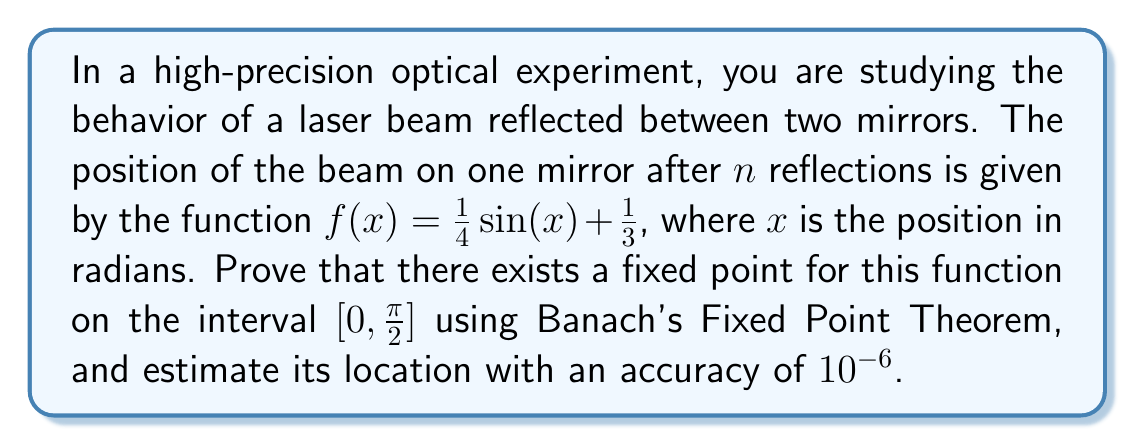Provide a solution to this math problem. To prove the existence of a fixed point using Banach's Fixed Point Theorem and estimate its location, we'll follow these steps:

1) First, we need to show that $f(x)$ maps $[0, \pi/2]$ to itself:
   For $x \in [0, \pi/2]$, 
   $0 \leq \sin(x) \leq 1$, so
   $\frac{1}{3} \leq f(x) = \frac{1}{4}\sin(x) + \frac{1}{3} \leq \frac{1}{4} + \frac{1}{3} = \frac{7}{12} < \frac{\pi}{2}$

2) Next, we need to prove that $f$ is a contraction mapping. We'll use the Mean Value Theorem:
   $|f'(x)| = |\frac{1}{4}\cos(x)| \leq \frac{1}{4} < 1$ for all $x \in [0, \pi/2]$
   Therefore, $|f(x) - f(y)| \leq \frac{1}{4}|x - y|$ for all $x, y \in [0, \pi/2]$

3) Since $[0, \pi/2]$ is a closed interval in $\mathbb{R}$, it's a complete metric space.

4) By Banach's Fixed Point Theorem, $f$ has a unique fixed point in $[0, \pi/2]$.

5) To estimate the fixed point, we'll use the iterative method:
   $x_{n+1} = f(x_n)$, starting with $x_0 = 0$

   $x_1 = f(0) = \frac{1}{3}$
   $x_2 = f(\frac{1}{3}) = \frac{1}{4}\sin(\frac{1}{3}) + \frac{1}{3} \approx 0.415729$
   $x_3 = f(0.415729) \approx 0.437443$
   $x_4 \approx 0.443983$
   $x_5 \approx 0.445869$
   $x_6 \approx 0.446453$
   $x_7 \approx 0.446628$
   $x_8 \approx 0.446685$
   $x_9 \approx 0.446702$
   $x_{10} \approx 0.446707$

6) The error estimate for the n-th iteration is:
   $|x_n - x^*| \leq \frac{k^n}{1-k}|x_1 - x_0|$, where $k$ is the contraction constant (1/4 in this case)

   For $n = 10$: $|x_{10} - x^*| \leq \frac{(1/4)^{10}}{1-1/4} \cdot \frac{1}{3} \approx 1.36 \times 10^{-7} < 10^{-6}$

Therefore, $x_{10} \approx 0.446707$ is an approximation of the fixed point with the required accuracy.
Answer: The function $f(x) = \frac{1}{4}\sin(x) + \frac{1}{3}$ has a unique fixed point in the interval $[0, \pi/2]$, and its approximate value to within $10^{-6}$ is 0.446707. 